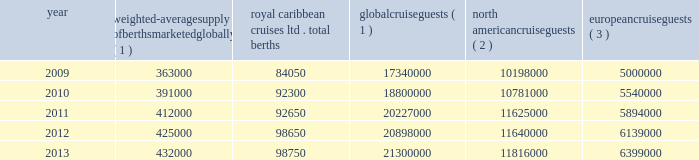Part i the table details the growth in global weighted average berths and the global , north american and european cruise guests over the past five years : weighted-average supply of berths marketed globally ( 1 ) royal caribbean cruises ltd .
Total berths global cruise guests ( 1 ) north american cruise guests ( 2 ) european cruise guests ( 3 ) .
( 1 ) source : our estimates of the number of global cruise guests and the weighted-average supply of berths marketed globally are based on a com- bination of data that we obtain from various publicly available cruise industry trade information sources including seatrade insider , cruise industry news and cruise line international association ( 201cclia 201d ) .
In addition , our estimates incorporate our own statistical analysis utilizing the same publicly available cruise industry data as a base .
( 2 ) source : cruise line international association based on cruise guests carried for at least two consecutive nights for years 2009 through 2012 .
Year 2013 amounts represent our estimates ( see number 1 above ) .
Includes the united states of america and canada .
( 3 ) source : clia europe , formerly european cruise council , for years 2009 through 2012 .
Year 2013 amounts represent our estimates ( see number 1 above ) .
North america the majority of cruise guests are sourced from north america , which represented approximately 56% ( 56 % ) of global cruise guests in 2013 .
The compound annual growth rate in cruise guests sourced from this market was approximately 3.2% ( 3.2 % ) from 2009 to 2013 .
Europe cruise guests sourced from europe represented approximately 30% ( 30 % ) of global cruise guests in 2013 .
The compound annual growth rate in cruise guests sourced from this market was approximately 6.0% ( 6.0 % ) from 2009 to 2013 .
Other markets in addition to expected industry growth in north america and europe , we expect the asia/pacific region to demonstrate an even higher growth rate in the near term , although it will continue to represent a relatively small sector compared to north america and europe .
Based on industry data , cruise guests sourced from the asia/pacific region represented approximately 4.5% ( 4.5 % ) of global cruise guests in 2013 .
The compound annual growth rate in cruise guests sourced from this market was approximately 15% ( 15 % ) from 2011 to 2013 .
Competition we compete with a number of cruise lines .
Our princi- pal competitors are carnival corporation & plc , which owns , among others , aida cruises , carnival cruise lines , costa cruises , cunard line , holland america line , iberocruceros , p&o cruises and princess cruises ; disney cruise line ; msc cruises ; norwegian cruise line and oceania cruises .
Cruise lines compete with other vacation alternatives such as land-based resort hotels and sightseeing destinations for consumers 2019 leisure time .
Demand for such activities is influenced by political and general economic conditions .
Com- panies within the vacation market are dependent on consumer discretionary spending .
Operating strategies our principal operating strategies are to : and employees and protect the environment in which our vessels and organization operate , to better serve our global guest base and grow our business , order to enhance our revenues , our brands globally , expenditures and ensure adequate cash and liquid- ity , with the overall goal of maximizing our return on invested capital and long-term shareholder value , ization and maintenance of existing ships and the transfer of key innovations across each brand , while prudently expanding our fleet with new state-of- the-art cruise ships , ships by deploying them into those markets and itineraries that provide opportunities to optimize returns , while continuing our focus on existing key markets , service customer preferences and expectations in an innovative manner , while supporting our strategic focus on profitability , and .
In 2010 what was the percent of the global cruise guests on the european cruise? 
Computations: (5540000 / 18800000)
Answer: 0.29468. 